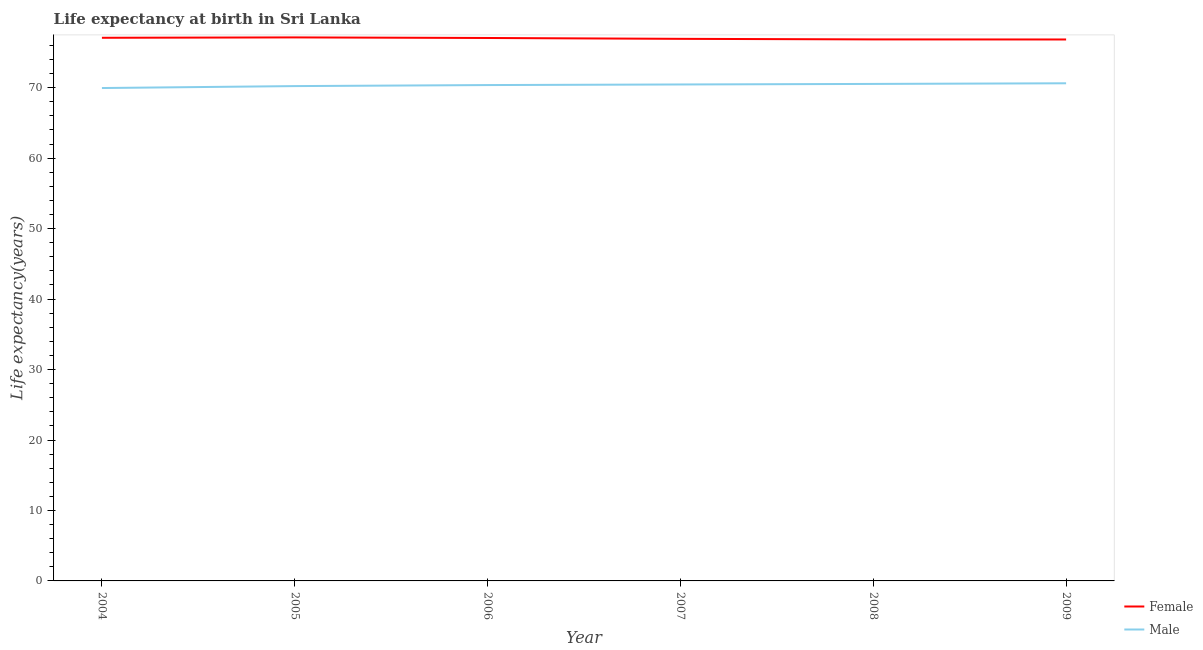Does the line corresponding to life expectancy(male) intersect with the line corresponding to life expectancy(female)?
Keep it short and to the point. No. Is the number of lines equal to the number of legend labels?
Offer a very short reply. Yes. What is the life expectancy(female) in 2006?
Your answer should be very brief. 77.06. Across all years, what is the maximum life expectancy(female)?
Offer a terse response. 77.14. Across all years, what is the minimum life expectancy(female)?
Offer a very short reply. 76.84. In which year was the life expectancy(male) maximum?
Your response must be concise. 2009. In which year was the life expectancy(male) minimum?
Give a very brief answer. 2004. What is the total life expectancy(female) in the graph?
Your answer should be very brief. 461.92. What is the difference between the life expectancy(male) in 2005 and that in 2009?
Offer a very short reply. -0.4. What is the difference between the life expectancy(female) in 2004 and the life expectancy(male) in 2007?
Give a very brief answer. 6.63. What is the average life expectancy(male) per year?
Keep it short and to the point. 70.36. In the year 2004, what is the difference between the life expectancy(male) and life expectancy(female)?
Give a very brief answer. -7.13. What is the ratio of the life expectancy(female) in 2005 to that in 2009?
Offer a very short reply. 1. Is the life expectancy(male) in 2004 less than that in 2008?
Provide a succinct answer. Yes. What is the difference between the highest and the second highest life expectancy(female)?
Your answer should be very brief. 0.05. What is the difference between the highest and the lowest life expectancy(female)?
Make the answer very short. 0.3. Does the life expectancy(male) monotonically increase over the years?
Your answer should be compact. Yes. How many lines are there?
Your answer should be compact. 2. How many years are there in the graph?
Offer a terse response. 6. What is the difference between two consecutive major ticks on the Y-axis?
Give a very brief answer. 10. Does the graph contain any zero values?
Keep it short and to the point. No. Does the graph contain grids?
Ensure brevity in your answer.  No. How many legend labels are there?
Offer a terse response. 2. How are the legend labels stacked?
Give a very brief answer. Vertical. What is the title of the graph?
Give a very brief answer. Life expectancy at birth in Sri Lanka. Does "Chemicals" appear as one of the legend labels in the graph?
Your response must be concise. No. What is the label or title of the Y-axis?
Your response must be concise. Life expectancy(years). What is the Life expectancy(years) of Female in 2004?
Make the answer very short. 77.09. What is the Life expectancy(years) of Male in 2004?
Your answer should be very brief. 69.95. What is the Life expectancy(years) of Female in 2005?
Provide a succinct answer. 77.14. What is the Life expectancy(years) of Male in 2005?
Offer a terse response. 70.23. What is the Life expectancy(years) in Female in 2006?
Give a very brief answer. 77.06. What is the Life expectancy(years) in Male in 2006?
Your answer should be very brief. 70.38. What is the Life expectancy(years) in Female in 2007?
Offer a terse response. 76.94. What is the Life expectancy(years) in Male in 2007?
Offer a very short reply. 70.46. What is the Life expectancy(years) of Female in 2008?
Provide a succinct answer. 76.86. What is the Life expectancy(years) of Male in 2008?
Provide a succinct answer. 70.54. What is the Life expectancy(years) in Female in 2009?
Your response must be concise. 76.84. What is the Life expectancy(years) in Male in 2009?
Give a very brief answer. 70.63. Across all years, what is the maximum Life expectancy(years) in Female?
Make the answer very short. 77.14. Across all years, what is the maximum Life expectancy(years) of Male?
Your answer should be compact. 70.63. Across all years, what is the minimum Life expectancy(years) of Female?
Ensure brevity in your answer.  76.84. Across all years, what is the minimum Life expectancy(years) of Male?
Make the answer very short. 69.95. What is the total Life expectancy(years) of Female in the graph?
Give a very brief answer. 461.92. What is the total Life expectancy(years) of Male in the graph?
Offer a terse response. 422.19. What is the difference between the Life expectancy(years) of Female in 2004 and that in 2005?
Offer a very short reply. -0.05. What is the difference between the Life expectancy(years) of Male in 2004 and that in 2005?
Make the answer very short. -0.28. What is the difference between the Life expectancy(years) of Female in 2004 and that in 2006?
Keep it short and to the point. 0.03. What is the difference between the Life expectancy(years) of Male in 2004 and that in 2006?
Your answer should be very brief. -0.42. What is the difference between the Life expectancy(years) of Female in 2004 and that in 2007?
Your answer should be compact. 0.15. What is the difference between the Life expectancy(years) in Male in 2004 and that in 2007?
Ensure brevity in your answer.  -0.51. What is the difference between the Life expectancy(years) of Female in 2004 and that in 2008?
Offer a very short reply. 0.23. What is the difference between the Life expectancy(years) of Male in 2004 and that in 2008?
Your response must be concise. -0.58. What is the difference between the Life expectancy(years) of Female in 2004 and that in 2009?
Provide a succinct answer. 0.24. What is the difference between the Life expectancy(years) of Male in 2004 and that in 2009?
Ensure brevity in your answer.  -0.67. What is the difference between the Life expectancy(years) of Female in 2005 and that in 2006?
Offer a terse response. 0.08. What is the difference between the Life expectancy(years) in Male in 2005 and that in 2006?
Your answer should be compact. -0.15. What is the difference between the Life expectancy(years) of Female in 2005 and that in 2007?
Your answer should be very brief. 0.2. What is the difference between the Life expectancy(years) in Male in 2005 and that in 2007?
Keep it short and to the point. -0.23. What is the difference between the Life expectancy(years) of Female in 2005 and that in 2008?
Make the answer very short. 0.28. What is the difference between the Life expectancy(years) in Male in 2005 and that in 2008?
Ensure brevity in your answer.  -0.31. What is the difference between the Life expectancy(years) in Female in 2005 and that in 2009?
Offer a very short reply. 0.29. What is the difference between the Life expectancy(years) of Male in 2005 and that in 2009?
Your answer should be very brief. -0.4. What is the difference between the Life expectancy(years) of Female in 2006 and that in 2007?
Offer a very short reply. 0.12. What is the difference between the Life expectancy(years) of Male in 2006 and that in 2007?
Offer a very short reply. -0.08. What is the difference between the Life expectancy(years) in Female in 2006 and that in 2008?
Provide a short and direct response. 0.2. What is the difference between the Life expectancy(years) of Male in 2006 and that in 2008?
Offer a terse response. -0.16. What is the difference between the Life expectancy(years) in Female in 2006 and that in 2009?
Provide a succinct answer. 0.21. What is the difference between the Life expectancy(years) of Male in 2006 and that in 2009?
Your answer should be compact. -0.25. What is the difference between the Life expectancy(years) in Female in 2007 and that in 2008?
Offer a terse response. 0.08. What is the difference between the Life expectancy(years) of Male in 2007 and that in 2008?
Offer a terse response. -0.08. What is the difference between the Life expectancy(years) of Female in 2007 and that in 2009?
Provide a succinct answer. 0.09. What is the difference between the Life expectancy(years) in Male in 2007 and that in 2009?
Offer a terse response. -0.17. What is the difference between the Life expectancy(years) in Female in 2008 and that in 2009?
Provide a short and direct response. 0.01. What is the difference between the Life expectancy(years) in Male in 2008 and that in 2009?
Your answer should be compact. -0.09. What is the difference between the Life expectancy(years) of Female in 2004 and the Life expectancy(years) of Male in 2005?
Provide a succinct answer. 6.86. What is the difference between the Life expectancy(years) of Female in 2004 and the Life expectancy(years) of Male in 2006?
Provide a succinct answer. 6.71. What is the difference between the Life expectancy(years) in Female in 2004 and the Life expectancy(years) in Male in 2007?
Your response must be concise. 6.63. What is the difference between the Life expectancy(years) in Female in 2004 and the Life expectancy(years) in Male in 2008?
Provide a succinct answer. 6.55. What is the difference between the Life expectancy(years) in Female in 2004 and the Life expectancy(years) in Male in 2009?
Your answer should be compact. 6.46. What is the difference between the Life expectancy(years) of Female in 2005 and the Life expectancy(years) of Male in 2006?
Offer a terse response. 6.76. What is the difference between the Life expectancy(years) of Female in 2005 and the Life expectancy(years) of Male in 2007?
Make the answer very short. 6.68. What is the difference between the Life expectancy(years) of Female in 2005 and the Life expectancy(years) of Male in 2008?
Give a very brief answer. 6.6. What is the difference between the Life expectancy(years) of Female in 2005 and the Life expectancy(years) of Male in 2009?
Give a very brief answer. 6.51. What is the difference between the Life expectancy(years) of Female in 2006 and the Life expectancy(years) of Male in 2007?
Ensure brevity in your answer.  6.6. What is the difference between the Life expectancy(years) in Female in 2006 and the Life expectancy(years) in Male in 2008?
Offer a very short reply. 6.52. What is the difference between the Life expectancy(years) in Female in 2006 and the Life expectancy(years) in Male in 2009?
Offer a terse response. 6.43. What is the difference between the Life expectancy(years) of Female in 2007 and the Life expectancy(years) of Male in 2008?
Ensure brevity in your answer.  6.4. What is the difference between the Life expectancy(years) in Female in 2007 and the Life expectancy(years) in Male in 2009?
Your response must be concise. 6.31. What is the difference between the Life expectancy(years) of Female in 2008 and the Life expectancy(years) of Male in 2009?
Keep it short and to the point. 6.23. What is the average Life expectancy(years) in Female per year?
Your answer should be compact. 76.99. What is the average Life expectancy(years) of Male per year?
Your answer should be very brief. 70.36. In the year 2004, what is the difference between the Life expectancy(years) of Female and Life expectancy(years) of Male?
Your answer should be compact. 7.13. In the year 2005, what is the difference between the Life expectancy(years) of Female and Life expectancy(years) of Male?
Keep it short and to the point. 6.91. In the year 2006, what is the difference between the Life expectancy(years) in Female and Life expectancy(years) in Male?
Offer a very short reply. 6.68. In the year 2007, what is the difference between the Life expectancy(years) of Female and Life expectancy(years) of Male?
Give a very brief answer. 6.48. In the year 2008, what is the difference between the Life expectancy(years) of Female and Life expectancy(years) of Male?
Offer a terse response. 6.32. In the year 2009, what is the difference between the Life expectancy(years) of Female and Life expectancy(years) of Male?
Keep it short and to the point. 6.22. What is the ratio of the Life expectancy(years) of Female in 2004 to that in 2006?
Offer a very short reply. 1. What is the ratio of the Life expectancy(years) of Female in 2005 to that in 2006?
Your response must be concise. 1. What is the ratio of the Life expectancy(years) in Female in 2005 to that in 2008?
Your answer should be very brief. 1. What is the ratio of the Life expectancy(years) of Male in 2005 to that in 2009?
Keep it short and to the point. 0.99. What is the ratio of the Life expectancy(years) of Male in 2006 to that in 2007?
Your response must be concise. 1. What is the ratio of the Life expectancy(years) in Male in 2006 to that in 2008?
Offer a very short reply. 1. What is the ratio of the Life expectancy(years) in Female in 2006 to that in 2009?
Make the answer very short. 1. What is the ratio of the Life expectancy(years) of Male in 2006 to that in 2009?
Provide a succinct answer. 1. What is the ratio of the Life expectancy(years) in Female in 2007 to that in 2008?
Ensure brevity in your answer.  1. What is the ratio of the Life expectancy(years) in Male in 2007 to that in 2008?
Provide a short and direct response. 1. What is the ratio of the Life expectancy(years) of Female in 2007 to that in 2009?
Make the answer very short. 1. What is the ratio of the Life expectancy(years) in Male in 2007 to that in 2009?
Make the answer very short. 1. What is the difference between the highest and the second highest Life expectancy(years) of Female?
Your response must be concise. 0.05. What is the difference between the highest and the second highest Life expectancy(years) in Male?
Make the answer very short. 0.09. What is the difference between the highest and the lowest Life expectancy(years) of Female?
Your answer should be compact. 0.29. What is the difference between the highest and the lowest Life expectancy(years) in Male?
Ensure brevity in your answer.  0.67. 